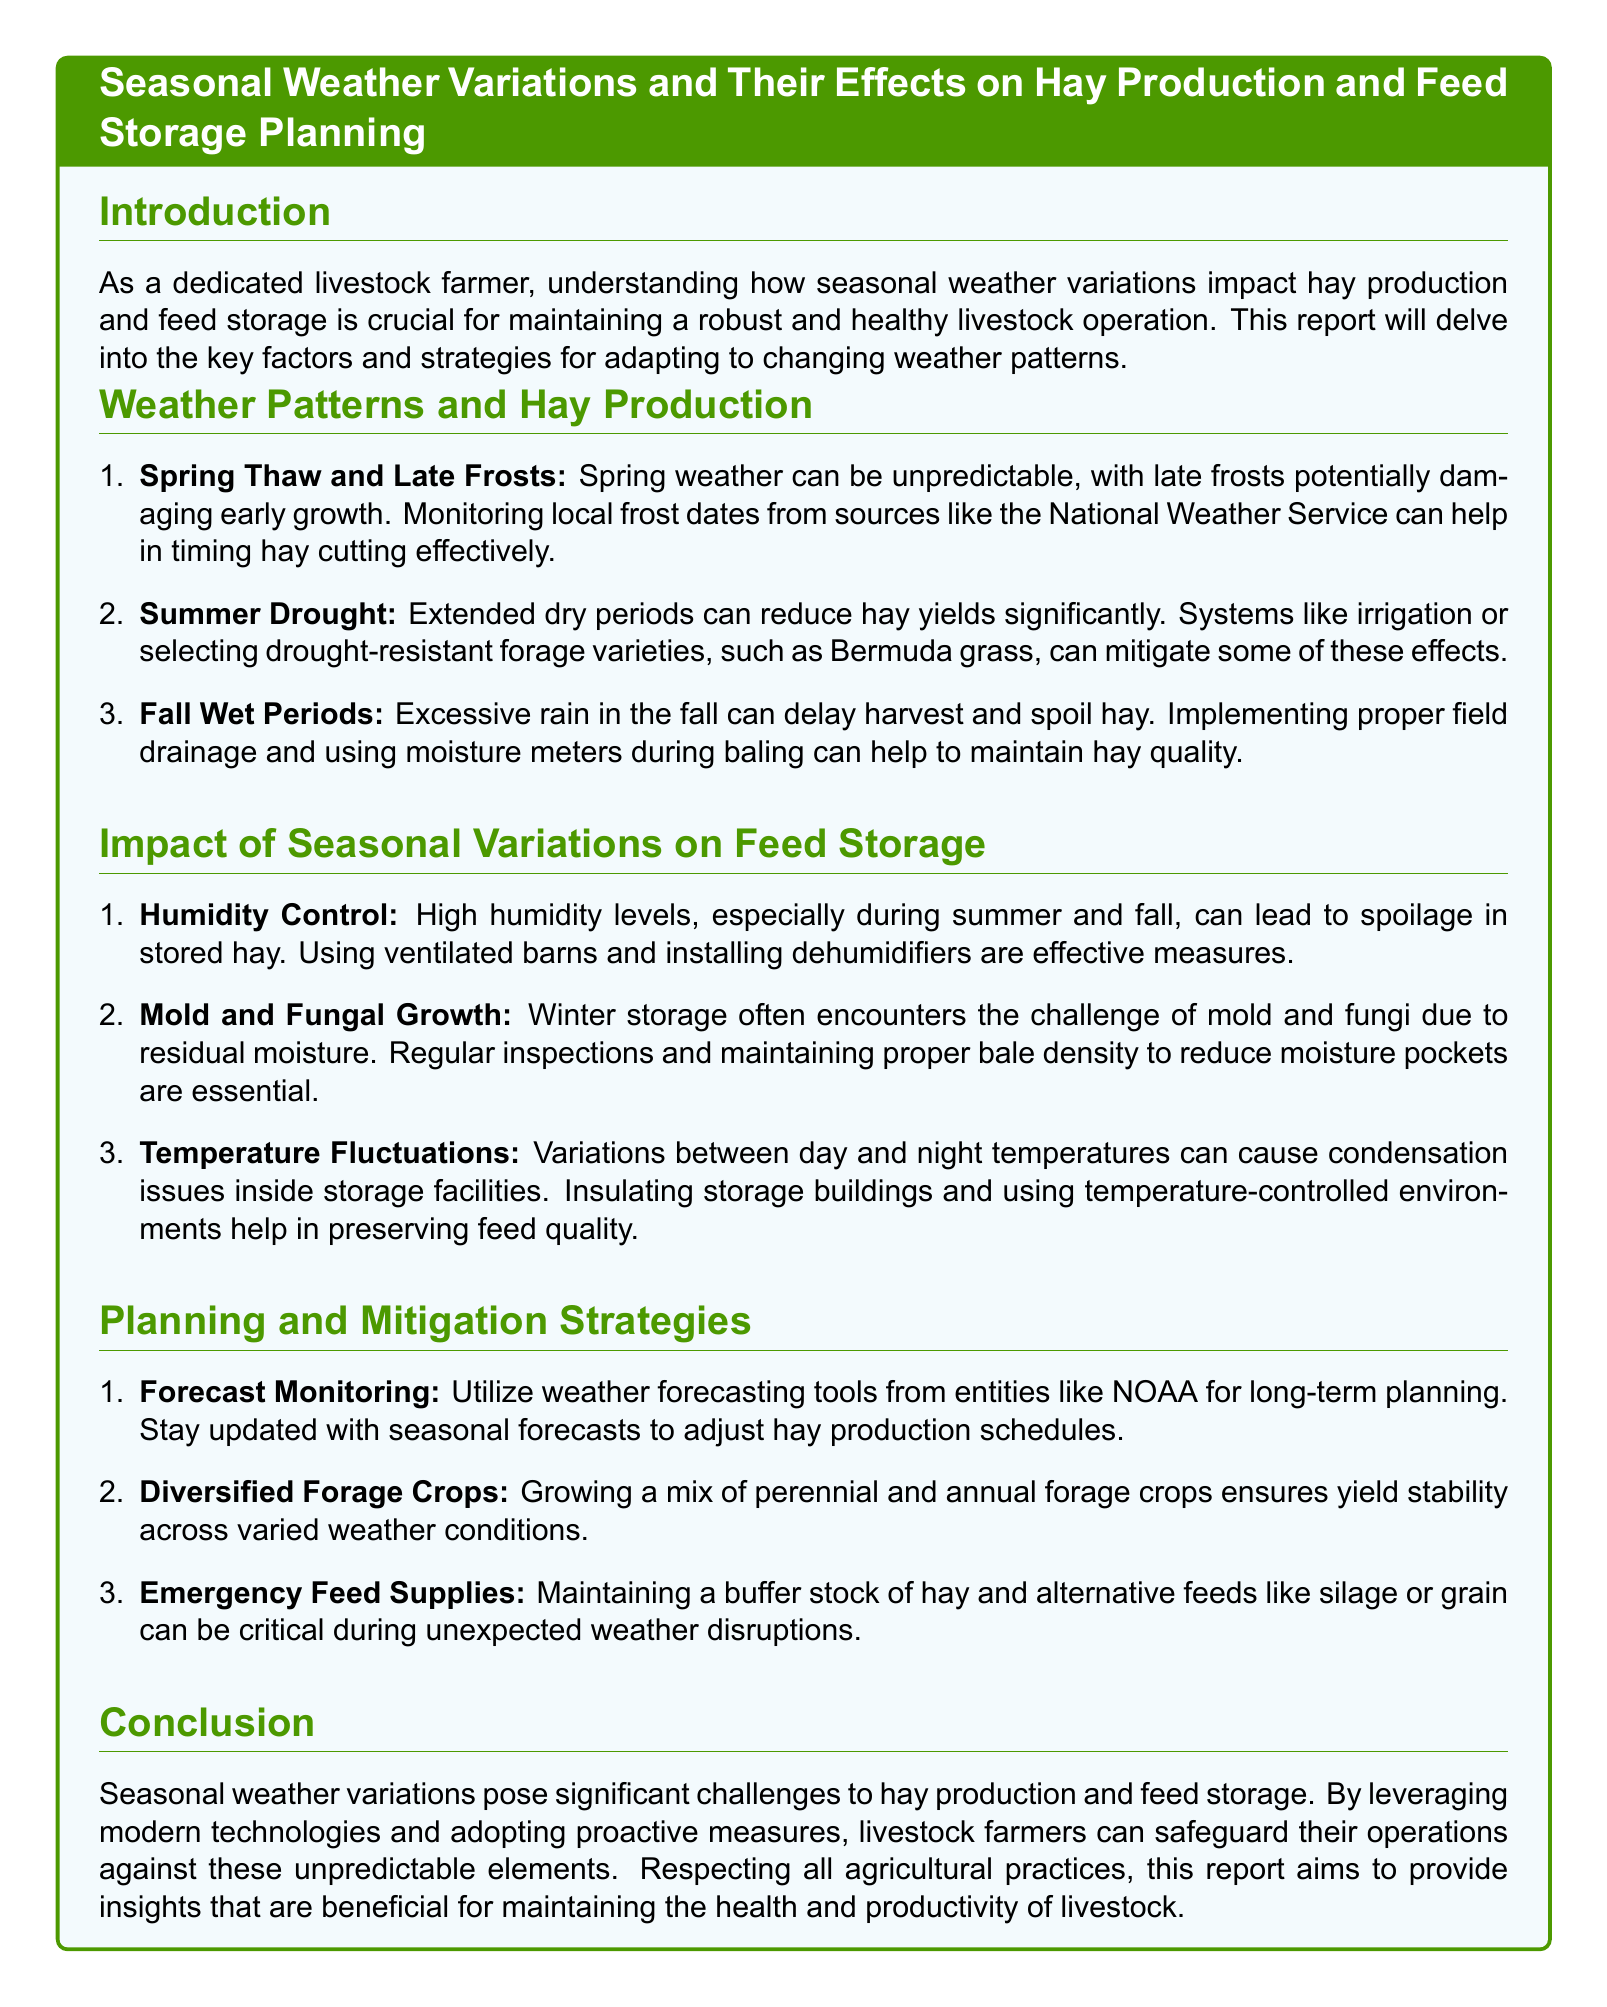What are the key weather factors affecting hay production? The document lists spring thaw and late frosts, summer drought, and fall wet periods as key weather factors impacting hay production.
Answer: spring thaw and late frosts, summer drought, fall wet periods What is a strategy to mitigate the effects of summer drought? The document mentions that using irrigation or selecting drought-resistant forage varieties, such as Bermuda grass, can help mitigate summer drought effects.
Answer: irrigation, drought-resistant varieties What does high humidity during summer and fall lead to in stored hay? High humidity levels can lead to spoilage in stored hay according to the document.
Answer: spoilage What is an emergency feed supply mentioned in the document? The document states that maintaining a buffer stock of hay and alternative feeds like silage or grain can be critical during unexpected weather disruptions.
Answer: hay, silage, grain What should be used for monitoring local frost dates? The document suggests checking sources like the National Weather Service for local frost dates.
Answer: National Weather Service How can temperature fluctuations affect feed storage? According to the document, temperature fluctuations can cause condensation issues inside storage facilities.
Answer: condensation issues What type of crop diversification is recommended? The document recommends growing a mix of perennial and annual forage crops for yield stability.
Answer: mix of perennial and annual forage crops How should farmers adapt to changing weather patterns? The document implies that leveraging modern technologies and adopting proactive measures is essential for adapting to changing weather patterns.
Answer: proactive measures 